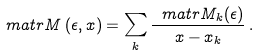<formula> <loc_0><loc_0><loc_500><loc_500>\ m a t r { M } \left ( \epsilon , x \right ) = \sum _ { k } \frac { \ m a t r { M } _ { k } ( \epsilon ) } { x - x _ { k } } \, .</formula> 